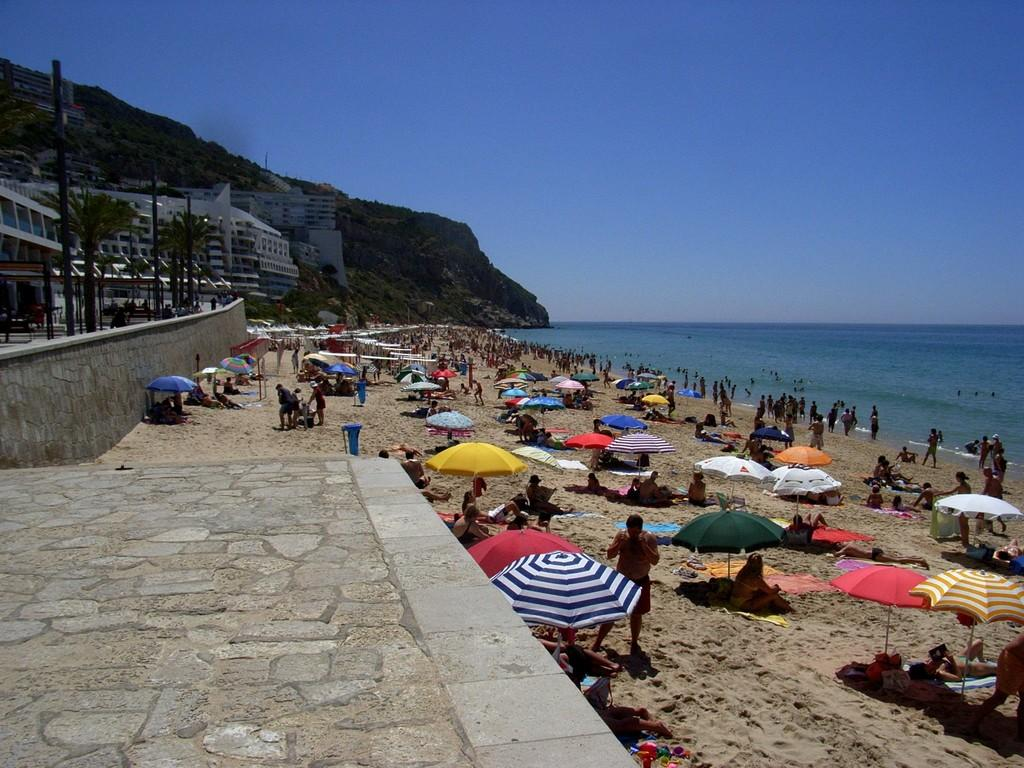What are the people in the image doing? There are people sitting, standing, and lying down in the image. Where is the location of the image? The location is at the seashore. What objects are present for shade in the image? There are parasols in the image. What objects are present for waste disposal in the image? There are trash bins in the image. What type of structures can be seen in the image? There are buildings in the image. What type of vegetation can be seen in the image? There are trees in the image. What type of poles can be seen in the image? There are poles in the image. What natural feature is visible in the image? The sea is visible in the image. What part of the sky is visible in the image? The sky is visible in the image. How many ducks are taking care of the carpenter in the image? There are no ducks or carpenters present in the image. 